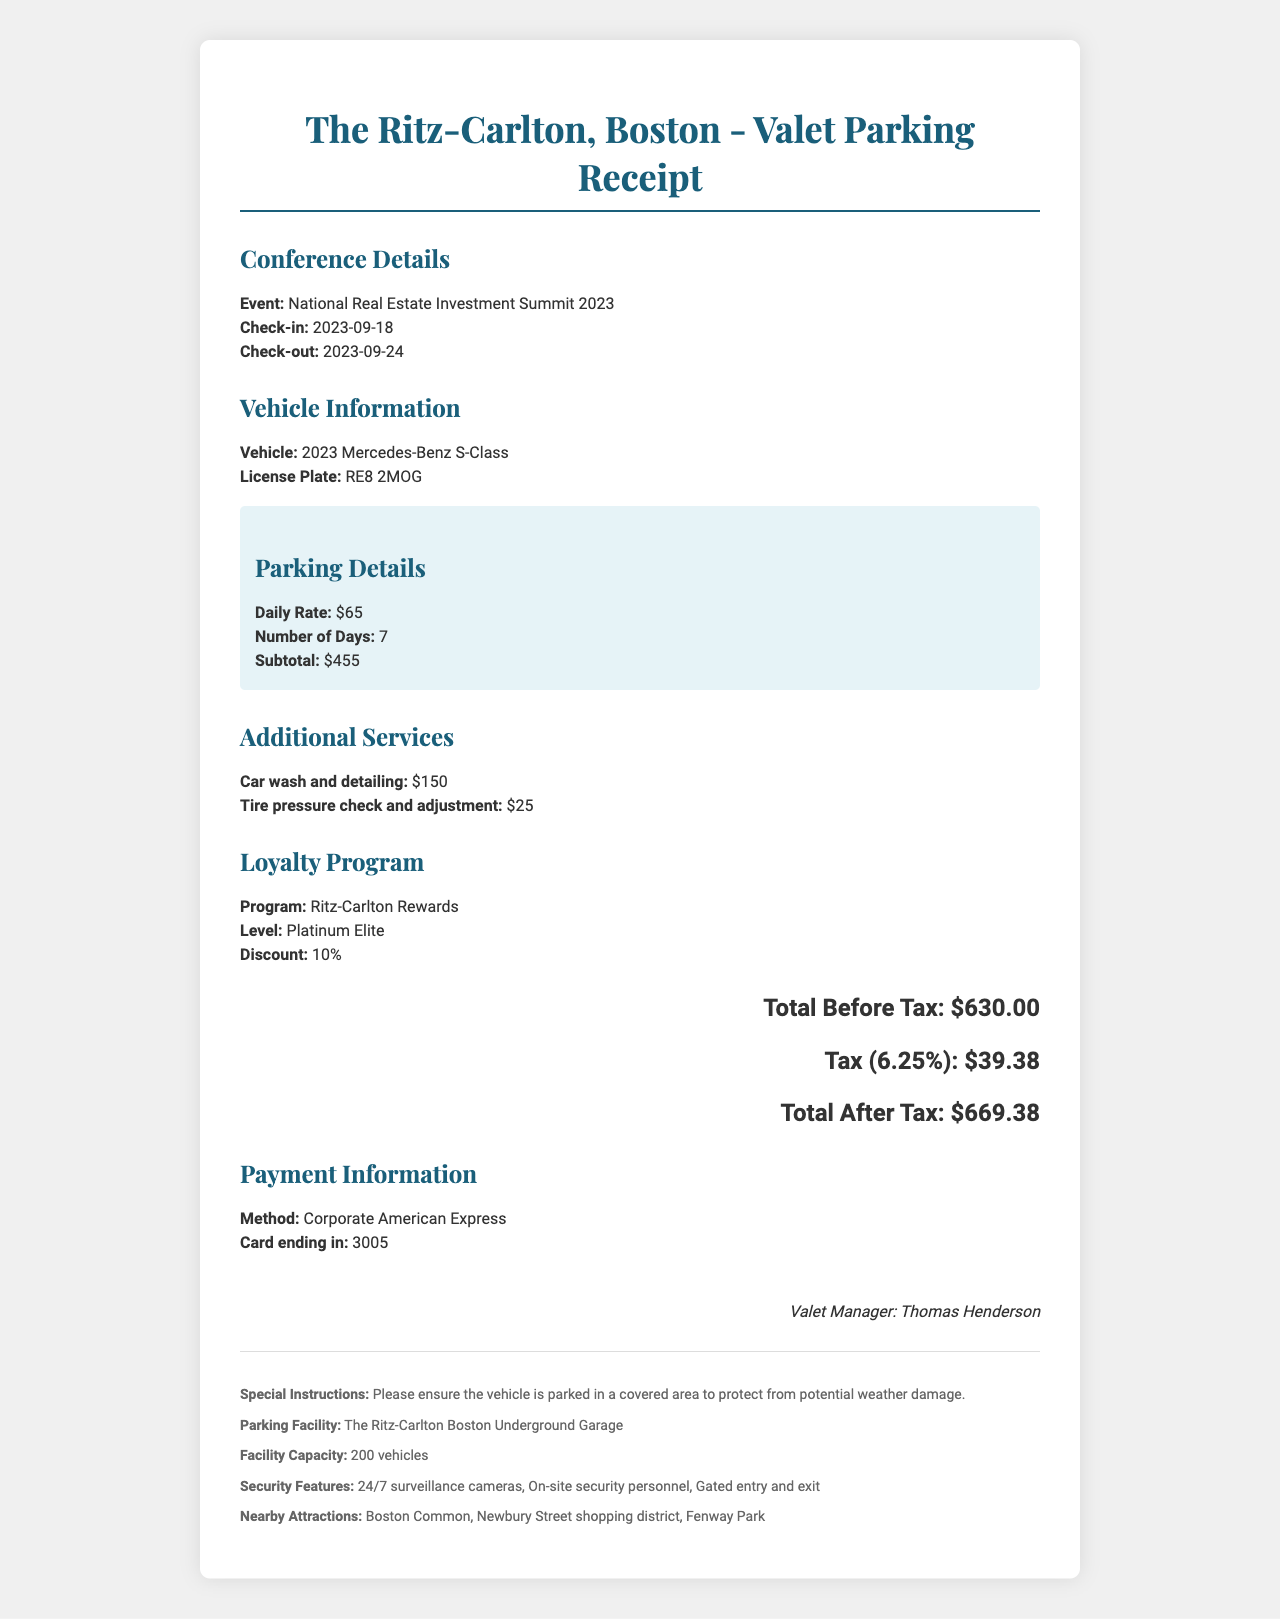What is the total after tax? The total after tax is calculated as the sum of the total before tax and the tax amount, resulting in $630 + $39.38 = $669.38.
Answer: $669.38 What is the daily rate for valet parking? The daily rate for valet parking is explicitly stated in the document.
Answer: $65 What vehicle type is mentioned in the receipt? The vehicle type is specified in the valet parking details of the document.
Answer: 2023 Mercedes-Benz S-Class How many days was the valet parking service used? The number of days is indicated in the valet parking details.
Answer: 7 What is the loyalty program membership level? The loyalty program membership level is provided in the loyalty program section of the document.
Answer: Platinum Elite What is the cost of the car wash and detailing service? The cost of the car wash and detailing service is listed under additional services.
Answer: $150 What is the total tax amount? The tax amount is stated clearly in the total calculations section of the document.
Answer: $39.38 Who is the valet manager? The valet manager's name is located in the signature section of the document.
Answer: Thomas Henderson What special instruction was given for the vehicle? The special instruction for the vehicle is detailed in a specific section of the document.
Answer: Please ensure the vehicle is parked in a covered area to protect from potential weather damage 